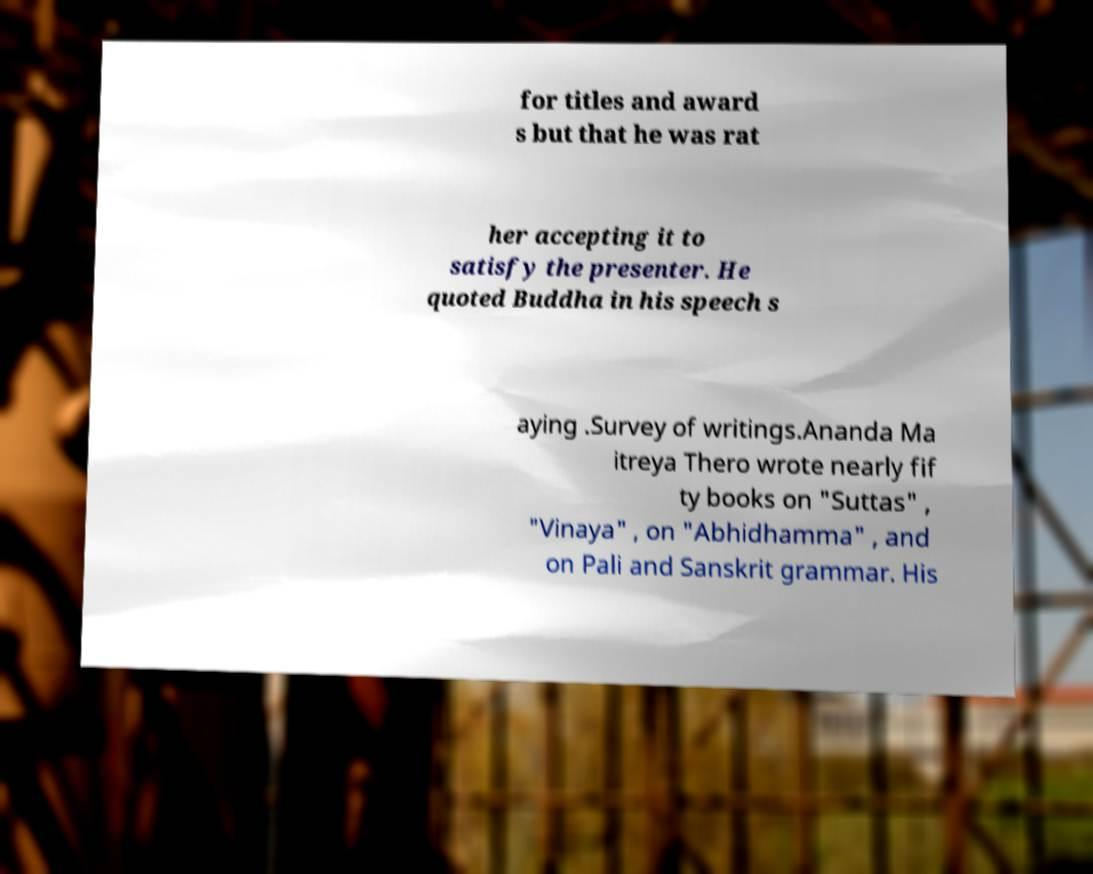I need the written content from this picture converted into text. Can you do that? for titles and award s but that he was rat her accepting it to satisfy the presenter. He quoted Buddha in his speech s aying .Survey of writings.Ananda Ma itreya Thero wrote nearly fif ty books on "Suttas" , "Vinaya" , on "Abhidhamma" , and on Pali and Sanskrit grammar. His 